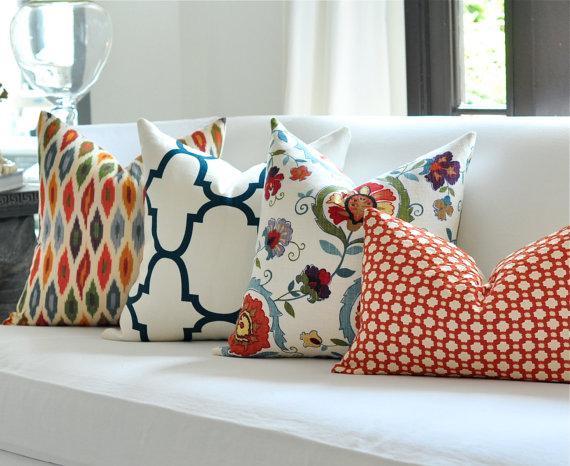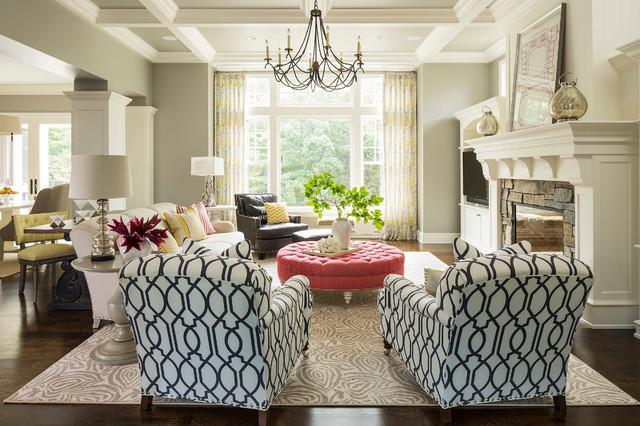The first image is the image on the left, the second image is the image on the right. For the images displayed, is the sentence "There are ten pillows total." factually correct? Answer yes or no. No. The first image is the image on the left, the second image is the image on the right. Analyze the images presented: Is the assertion "There are four different pillow sitting on a cream colored sofa." valid? Answer yes or no. Yes. 